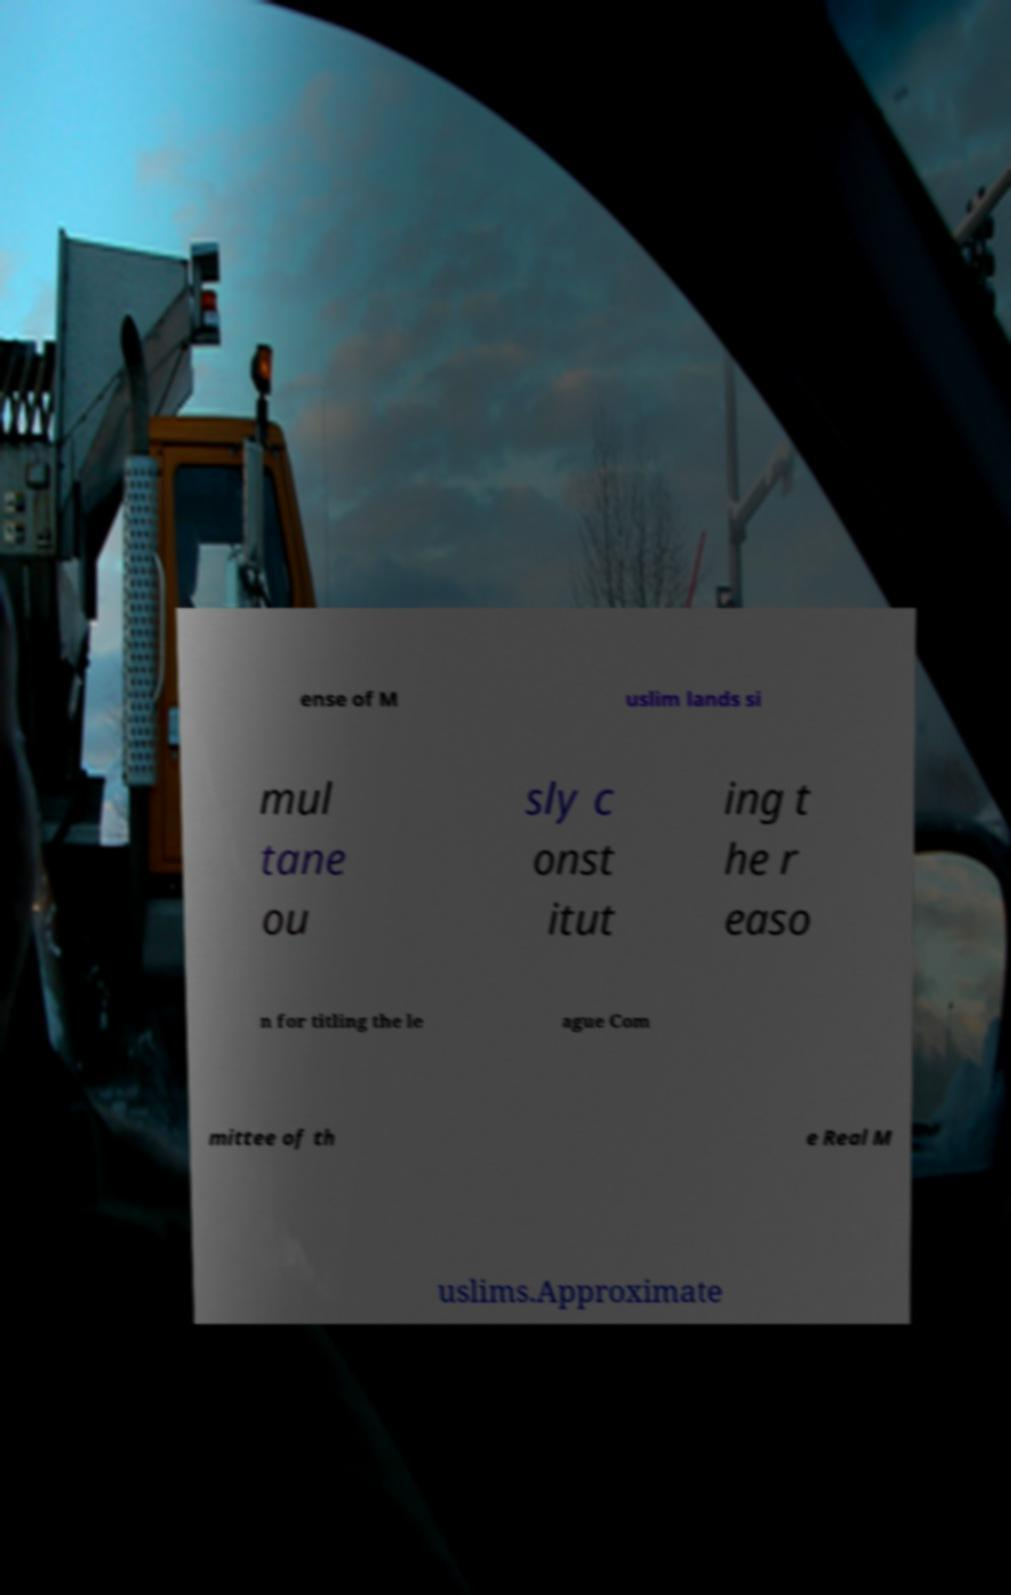For documentation purposes, I need the text within this image transcribed. Could you provide that? ense of M uslim lands si mul tane ou sly c onst itut ing t he r easo n for titling the le ague Com mittee of th e Real M uslims.Approximate 